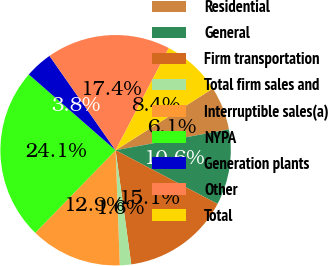Convert chart to OTSL. <chart><loc_0><loc_0><loc_500><loc_500><pie_chart><fcel>Residential<fcel>General<fcel>Firm transportation<fcel>Total firm sales and<fcel>Interruptible sales(a)<fcel>NYPA<fcel>Generation plants<fcel>Other<fcel>Total<nl><fcel>6.1%<fcel>10.61%<fcel>15.12%<fcel>1.59%<fcel>12.86%<fcel>24.14%<fcel>3.85%<fcel>17.37%<fcel>8.36%<nl></chart> 